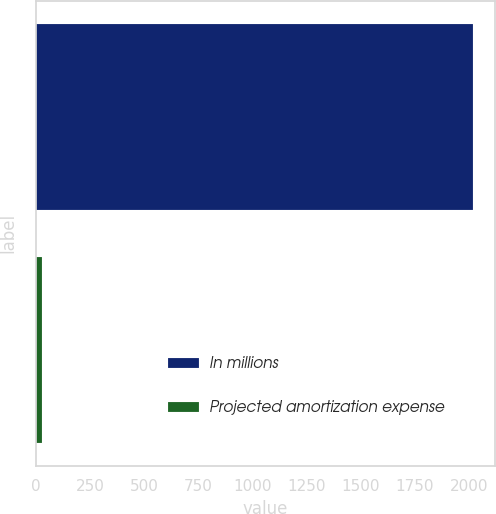Convert chart to OTSL. <chart><loc_0><loc_0><loc_500><loc_500><bar_chart><fcel>In millions<fcel>Projected amortization expense<nl><fcel>2018<fcel>27<nl></chart> 